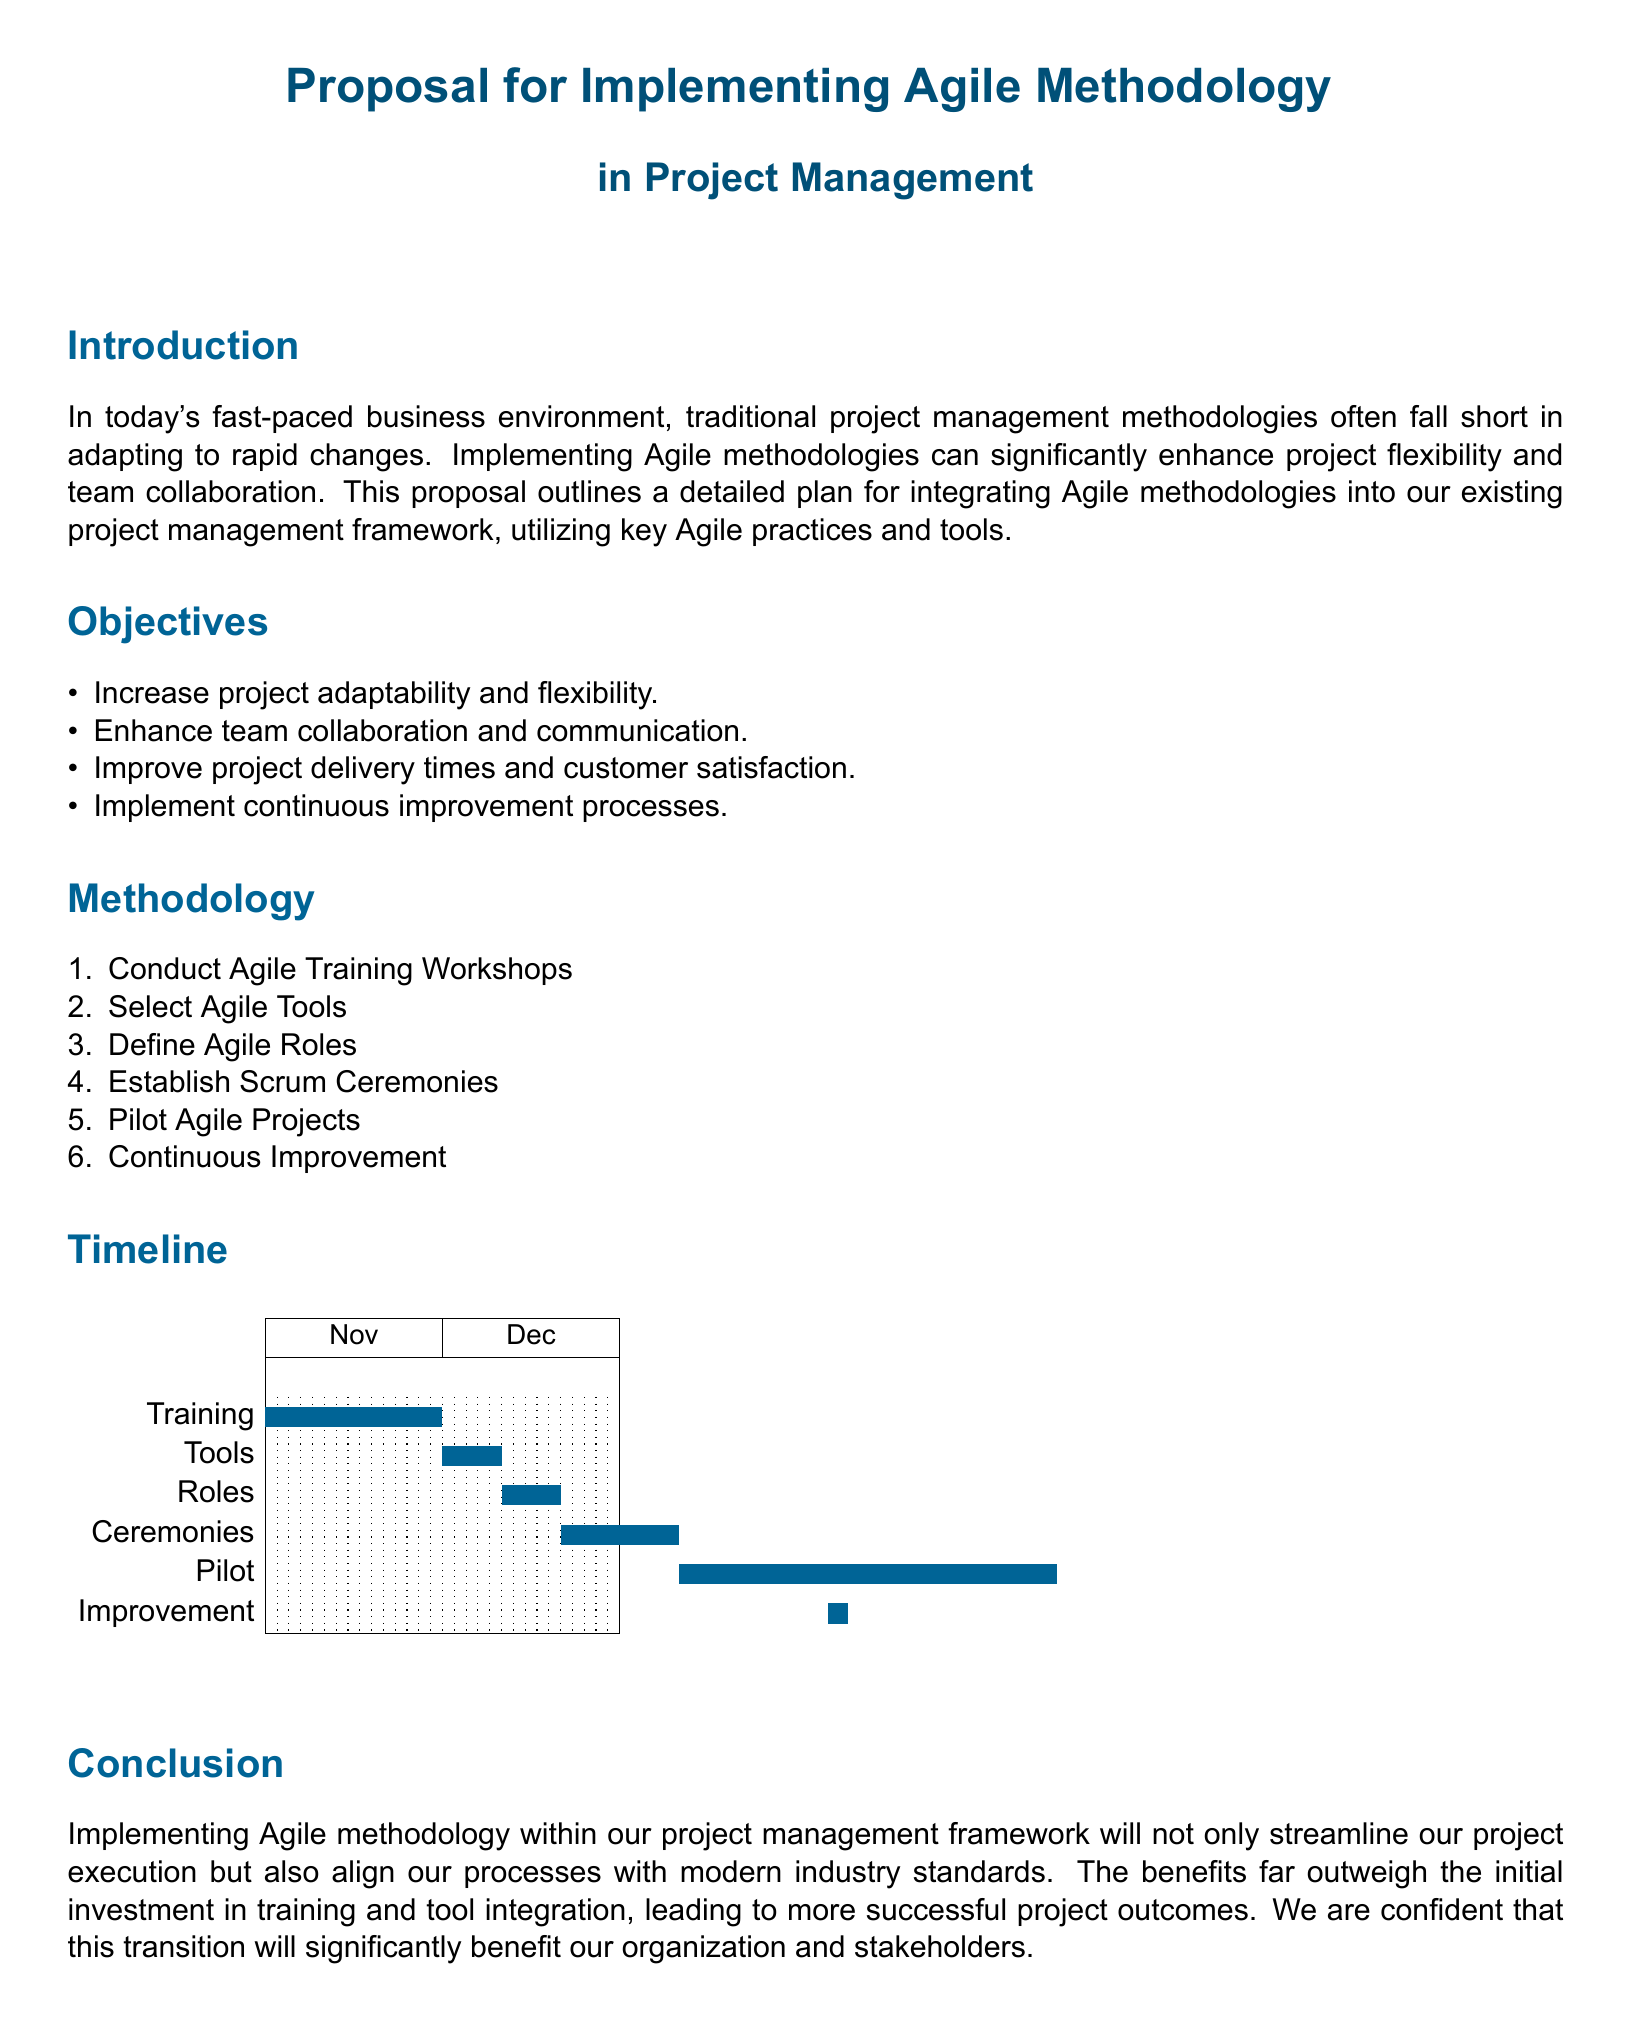What is the main purpose of the proposal? The proposal outlines a plan for integrating Agile methodologies into the existing project management framework.
Answer: To integrate Agile methodologies What is the first objective listed? The objectives section lists four goals; the first is mentioned explicitly.
Answer: Increase project adaptability and flexibility How many Agile Training Workshops are proposed? The methodology section mentions conducting one type of workshop.
Answer: One What is the timeline for the 'Pilot Agile Projects' phase? The Gantt chart indicates the duration for this phase from start to end.
Answer: 36 to 67 What is the color used for the Gantt chart bars? The document specifies the color used for the bars in the Gantt chart.
Answer: Section color What is the last phase in the timeline? The last activity in the Gantt chart denotes what comes after pilot projects.
Answer: Continuous Improvement What are Scrum Ceremonies? This term refers to one of the steps outlined in the methodology.
Answer: Establish Scrum Ceremonies How long does the training phase last? The Gantt chart specifies the start and end days for training.
Answer: 15 days What is the overall benefit expected from implementing Agile methodology? The conclusion highlights an overarching advantage stated in the proposal.
Answer: More successful project outcomes 